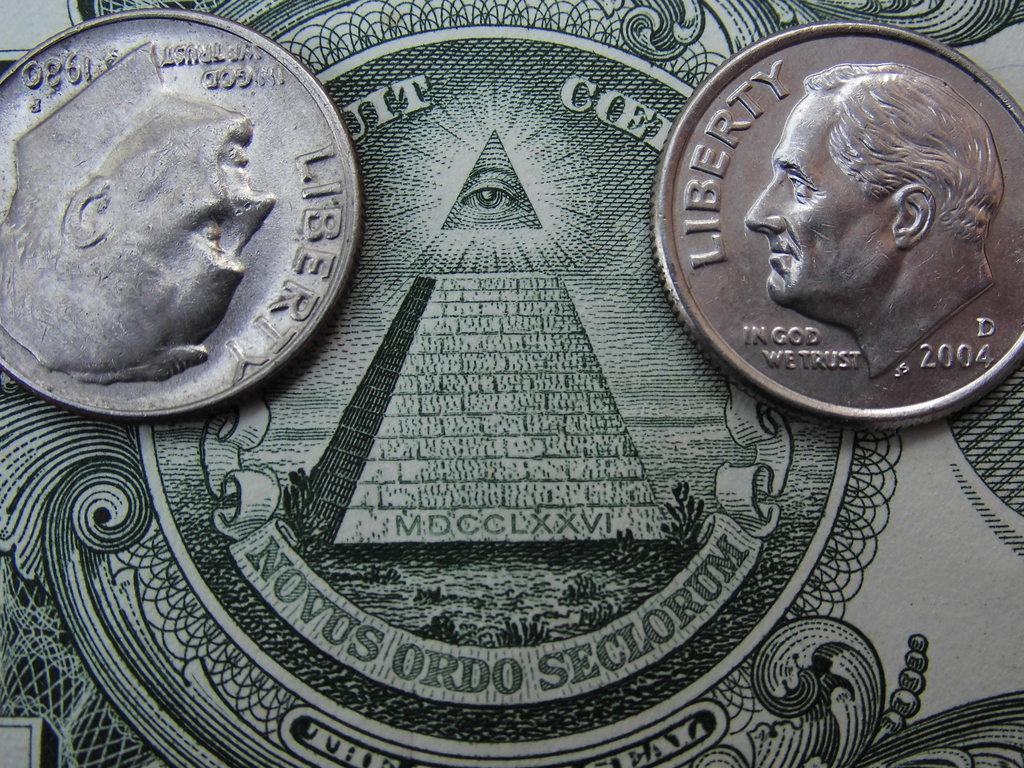<image>
Summarize the visual content of the image. Two dimes are on a dollar bill, above the Novus Ordo Seclorum banner. 